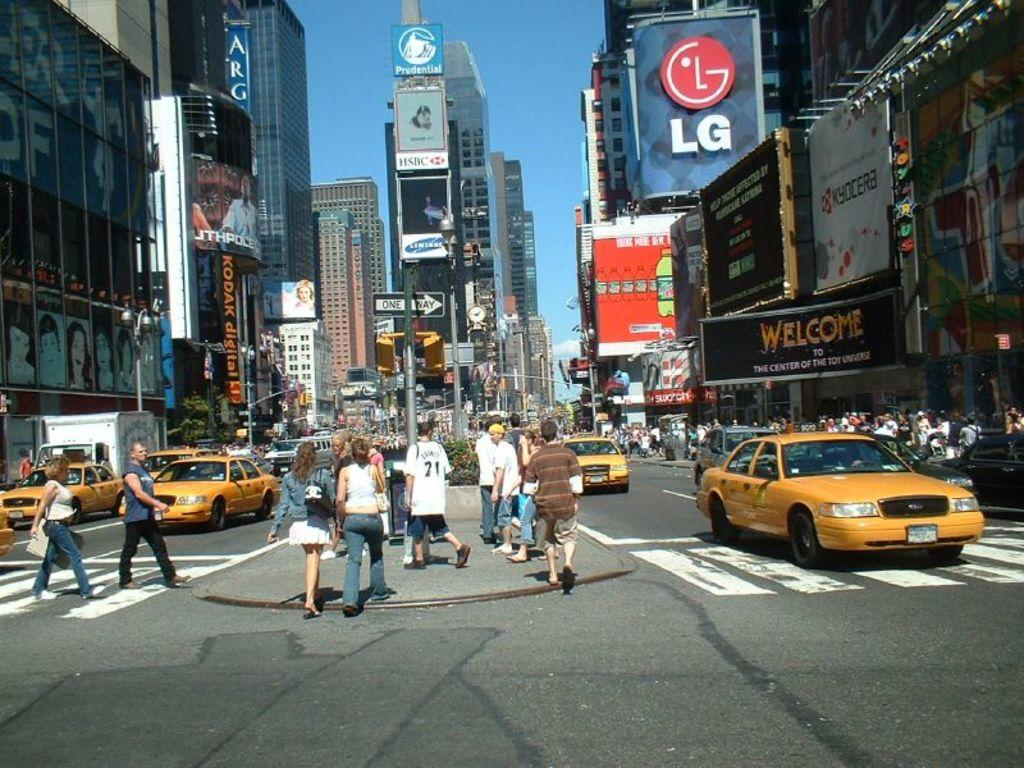<image>
Describe the image concisely. A busy city street with the letters LG on a billboard 